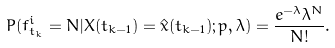Convert formula to latex. <formula><loc_0><loc_0><loc_500><loc_500>P ( f ^ { i } _ { t _ { k } } = N | X ( t _ { k - 1 } ) = \hat { x } ( t _ { k - 1 } ) ; p , \lambda ) = \frac { e ^ { - \lambda } { \lambda } ^ { N } } { N ! } .</formula> 